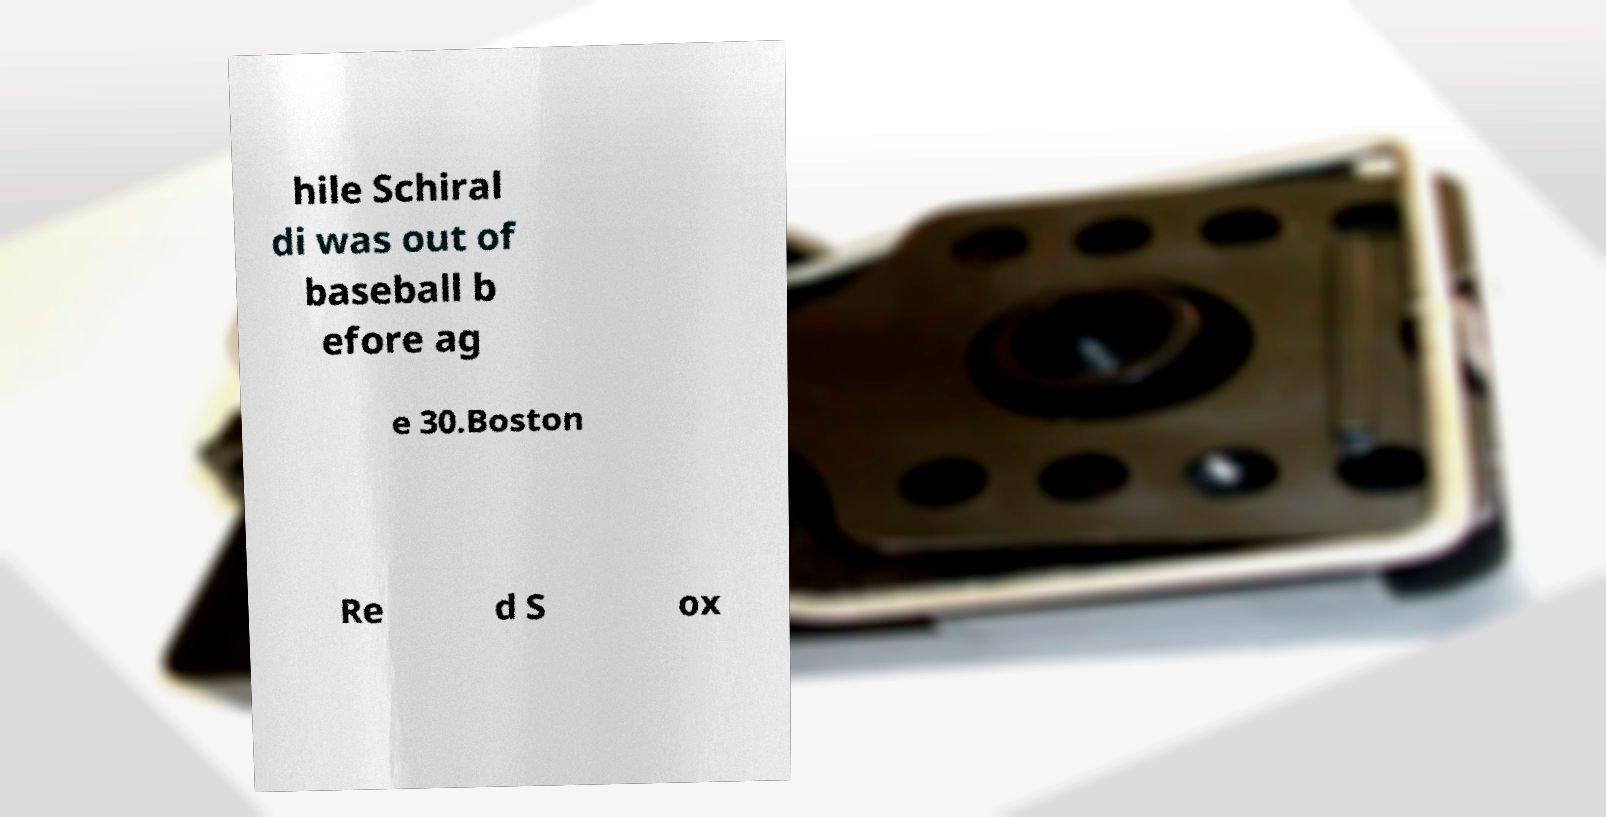Can you accurately transcribe the text from the provided image for me? hile Schiral di was out of baseball b efore ag e 30.Boston Re d S ox 